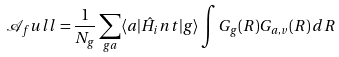Convert formula to latex. <formula><loc_0><loc_0><loc_500><loc_500>\mathcal { A } _ { f } u l l = \frac { 1 } { N _ { g } } \sum _ { g a } \langle a | \hat { H } _ { i } n t | g \rangle \int G _ { g } ( R ) G _ { a , v } ( R ) \, d R</formula> 